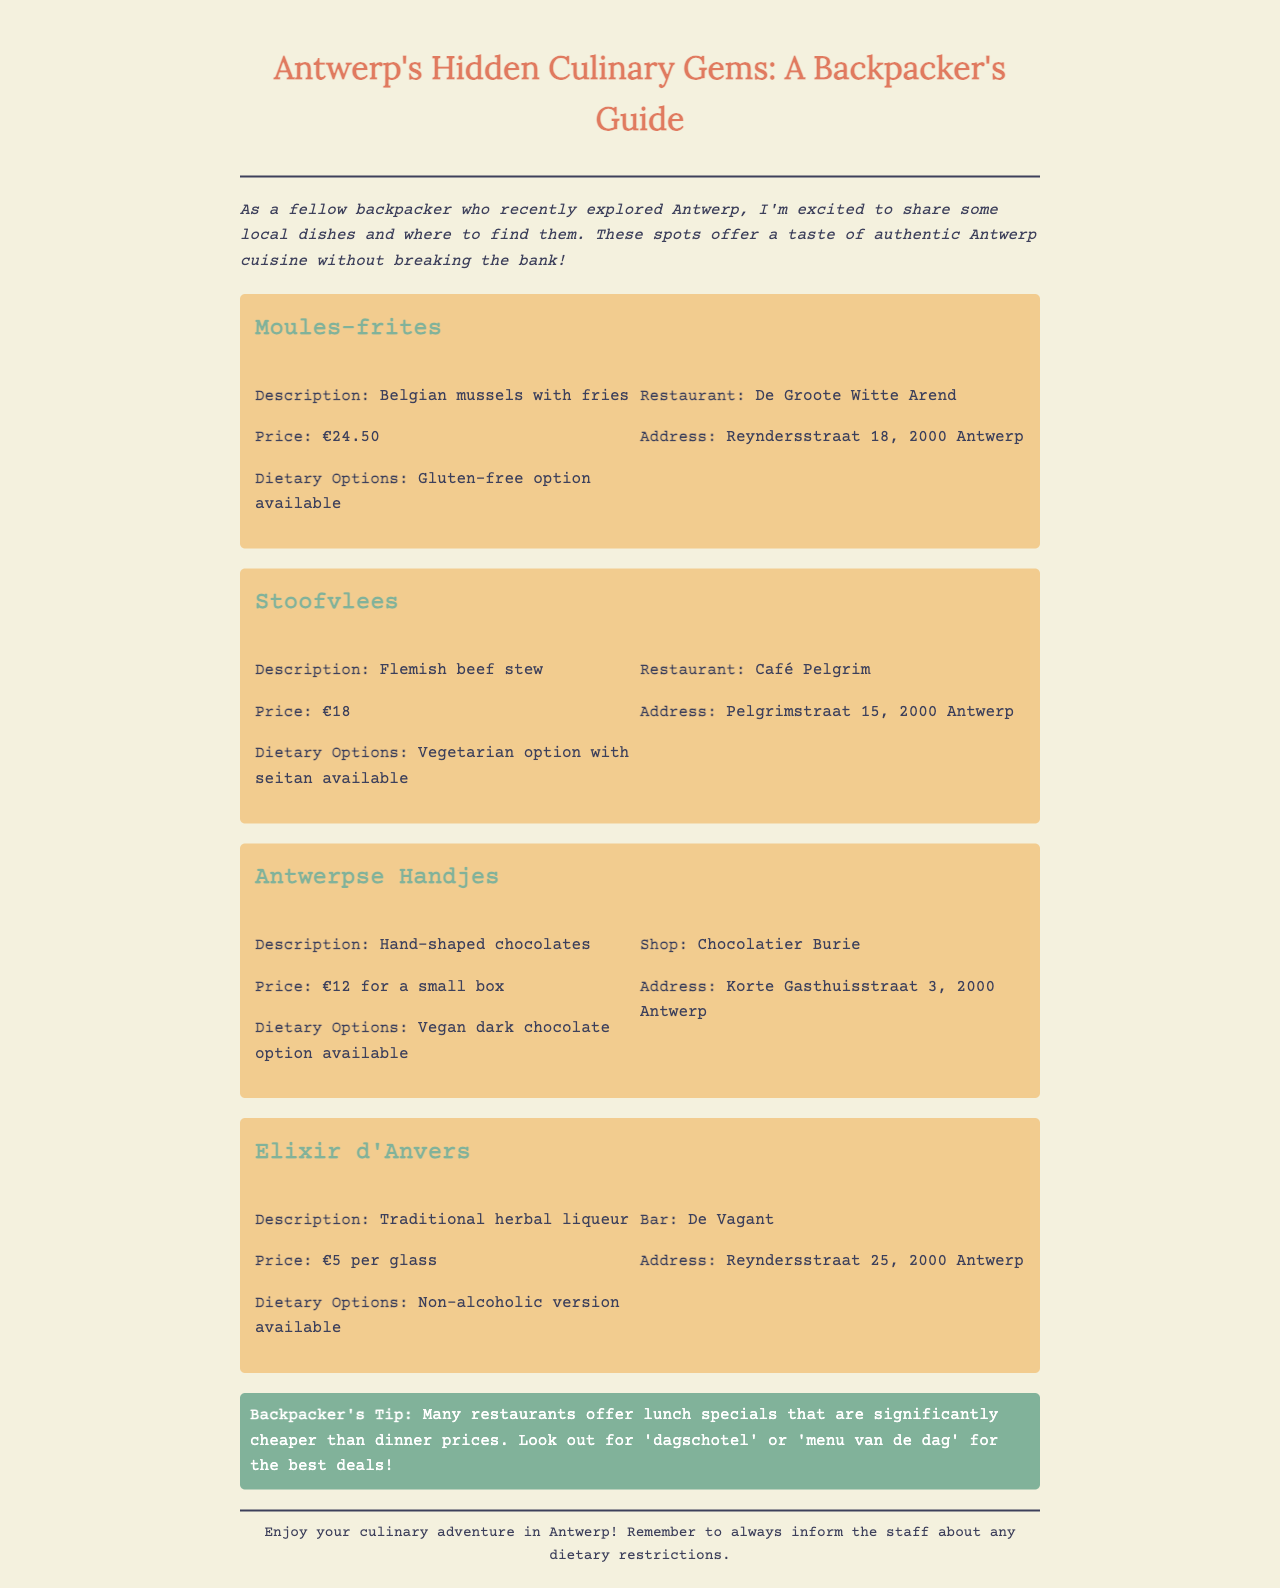What is the price of Moules-frites? The price of Moules-frites is mentioned in the document as €24.50.
Answer: €24.50 Where can you find Stoofvlees? The document specifies that Stoofvlees can be found at Café Pelgrim.
Answer: Café Pelgrim What type of dietary option is available for Antwerpse Handjes? The dietary option available for Antwerpse Handjes is a vegan dark chocolate option.
Answer: Vegan dark chocolate option What is Elixir d'Anvers? Elixir d'Anvers is described in the document as a traditional herbal liqueur.
Answer: Traditional herbal liqueur What is a tip mentioned for backpackers? The document provides a tip stating that many restaurants offer lunch specials that are cheaper than dinner prices.
Answer: Lunch specials are cheaper What dish includes fries? The dish that includes fries is Moules-frites, as described in the document.
Answer: Moules-frites How much does a small box of Antwerpse Handjes cost? The document states that a small box of Antwerpse Handjes costs €12.
Answer: €12 What restaurant serves Elixir d'Anvers? The document specifies that Elixir d'Anvers is served at De Vagant.
Answer: De Vagant What is the address of Chocolatier Burie? The address of Chocolatier Burie is listed as Korte Gasthuisstraat 3, 2000 Antwerp.
Answer: Korte Gasthuisstraat 3, 2000 Antwerp 